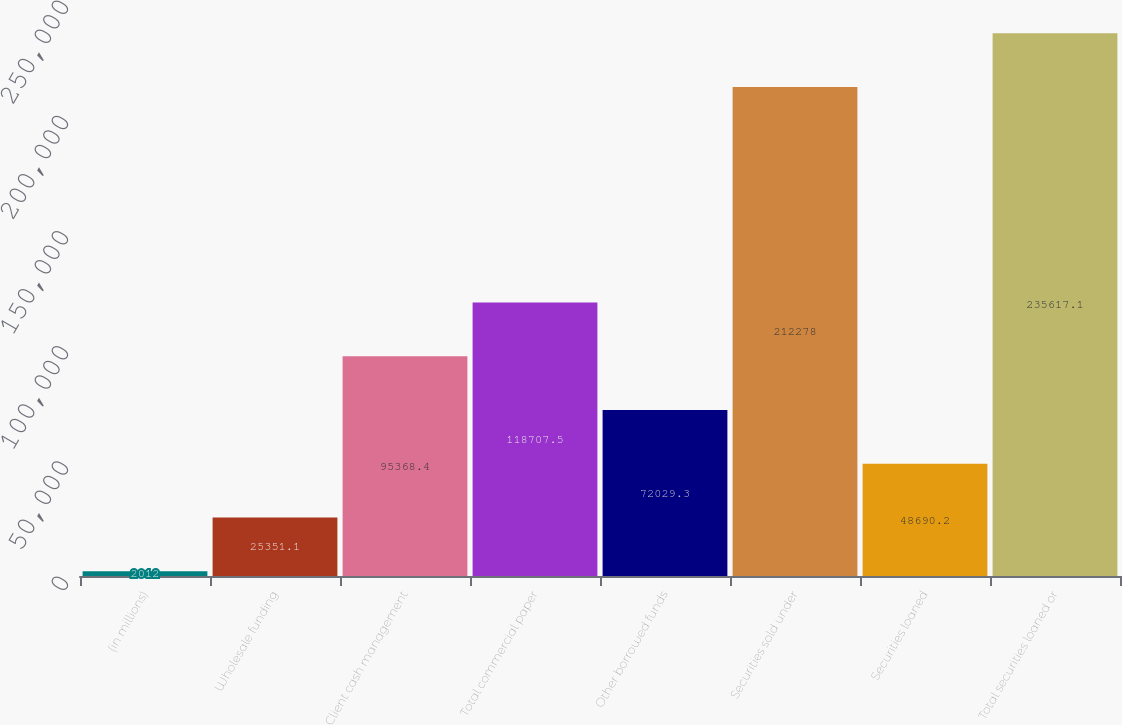Convert chart. <chart><loc_0><loc_0><loc_500><loc_500><bar_chart><fcel>(in millions)<fcel>Wholesale funding<fcel>Client cash management<fcel>Total commercial paper<fcel>Other borrowed funds<fcel>Securities sold under<fcel>Securities loaned<fcel>Total securities loaned or<nl><fcel>2012<fcel>25351.1<fcel>95368.4<fcel>118708<fcel>72029.3<fcel>212278<fcel>48690.2<fcel>235617<nl></chart> 